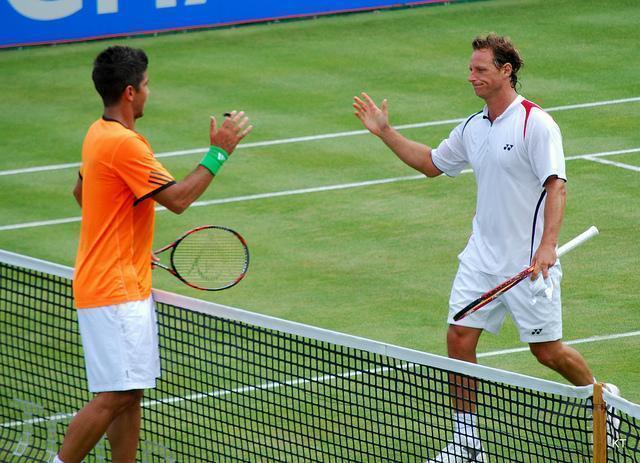What is the name of a famous player of this sport?
Answer the question by selecting the correct answer among the 4 following choices and explain your choice with a short sentence. The answer should be formatted with the following format: `Answer: choice
Rationale: rationale.`
Options: Johnson, sampras, botham, rooney. Answer: sampras.
Rationale: Pete sampras is a well know tennis player. 